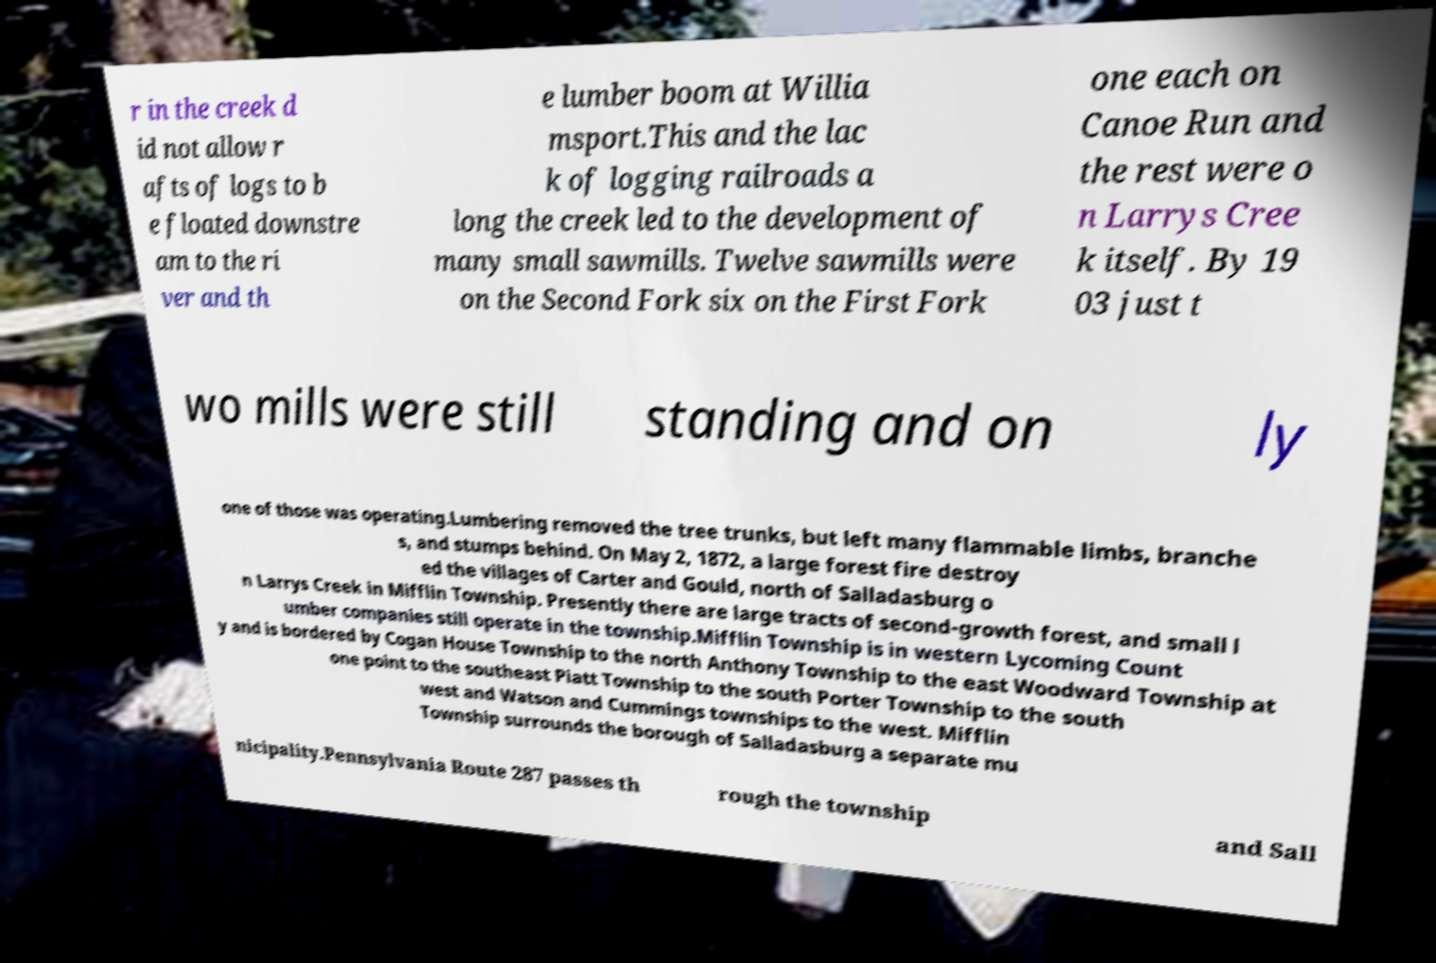Can you accurately transcribe the text from the provided image for me? r in the creek d id not allow r afts of logs to b e floated downstre am to the ri ver and th e lumber boom at Willia msport.This and the lac k of logging railroads a long the creek led to the development of many small sawmills. Twelve sawmills were on the Second Fork six on the First Fork one each on Canoe Run and the rest were o n Larrys Cree k itself. By 19 03 just t wo mills were still standing and on ly one of those was operating.Lumbering removed the tree trunks, but left many flammable limbs, branche s, and stumps behind. On May 2, 1872, a large forest fire destroy ed the villages of Carter and Gould, north of Salladasburg o n Larrys Creek in Mifflin Township. Presently there are large tracts of second-growth forest, and small l umber companies still operate in the township.Mifflin Township is in western Lycoming Count y and is bordered by Cogan House Township to the north Anthony Township to the east Woodward Township at one point to the southeast Piatt Township to the south Porter Township to the south west and Watson and Cummings townships to the west. Mifflin Township surrounds the borough of Salladasburg a separate mu nicipality.Pennsylvania Route 287 passes th rough the township and Sall 